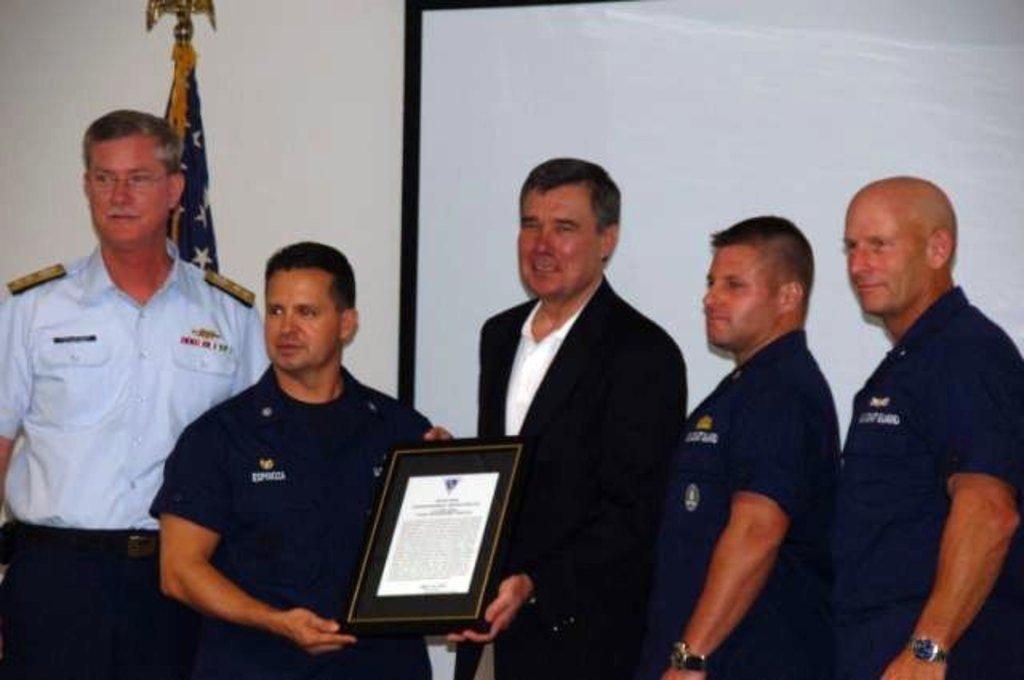Can you describe this image briefly? There is a group of persons standing at the bottom of this image. The persons standing in the middle is holding a frame. There is a wall in the background. There is a white color board on the right side of this image and there is a flag on the left side of this image. 